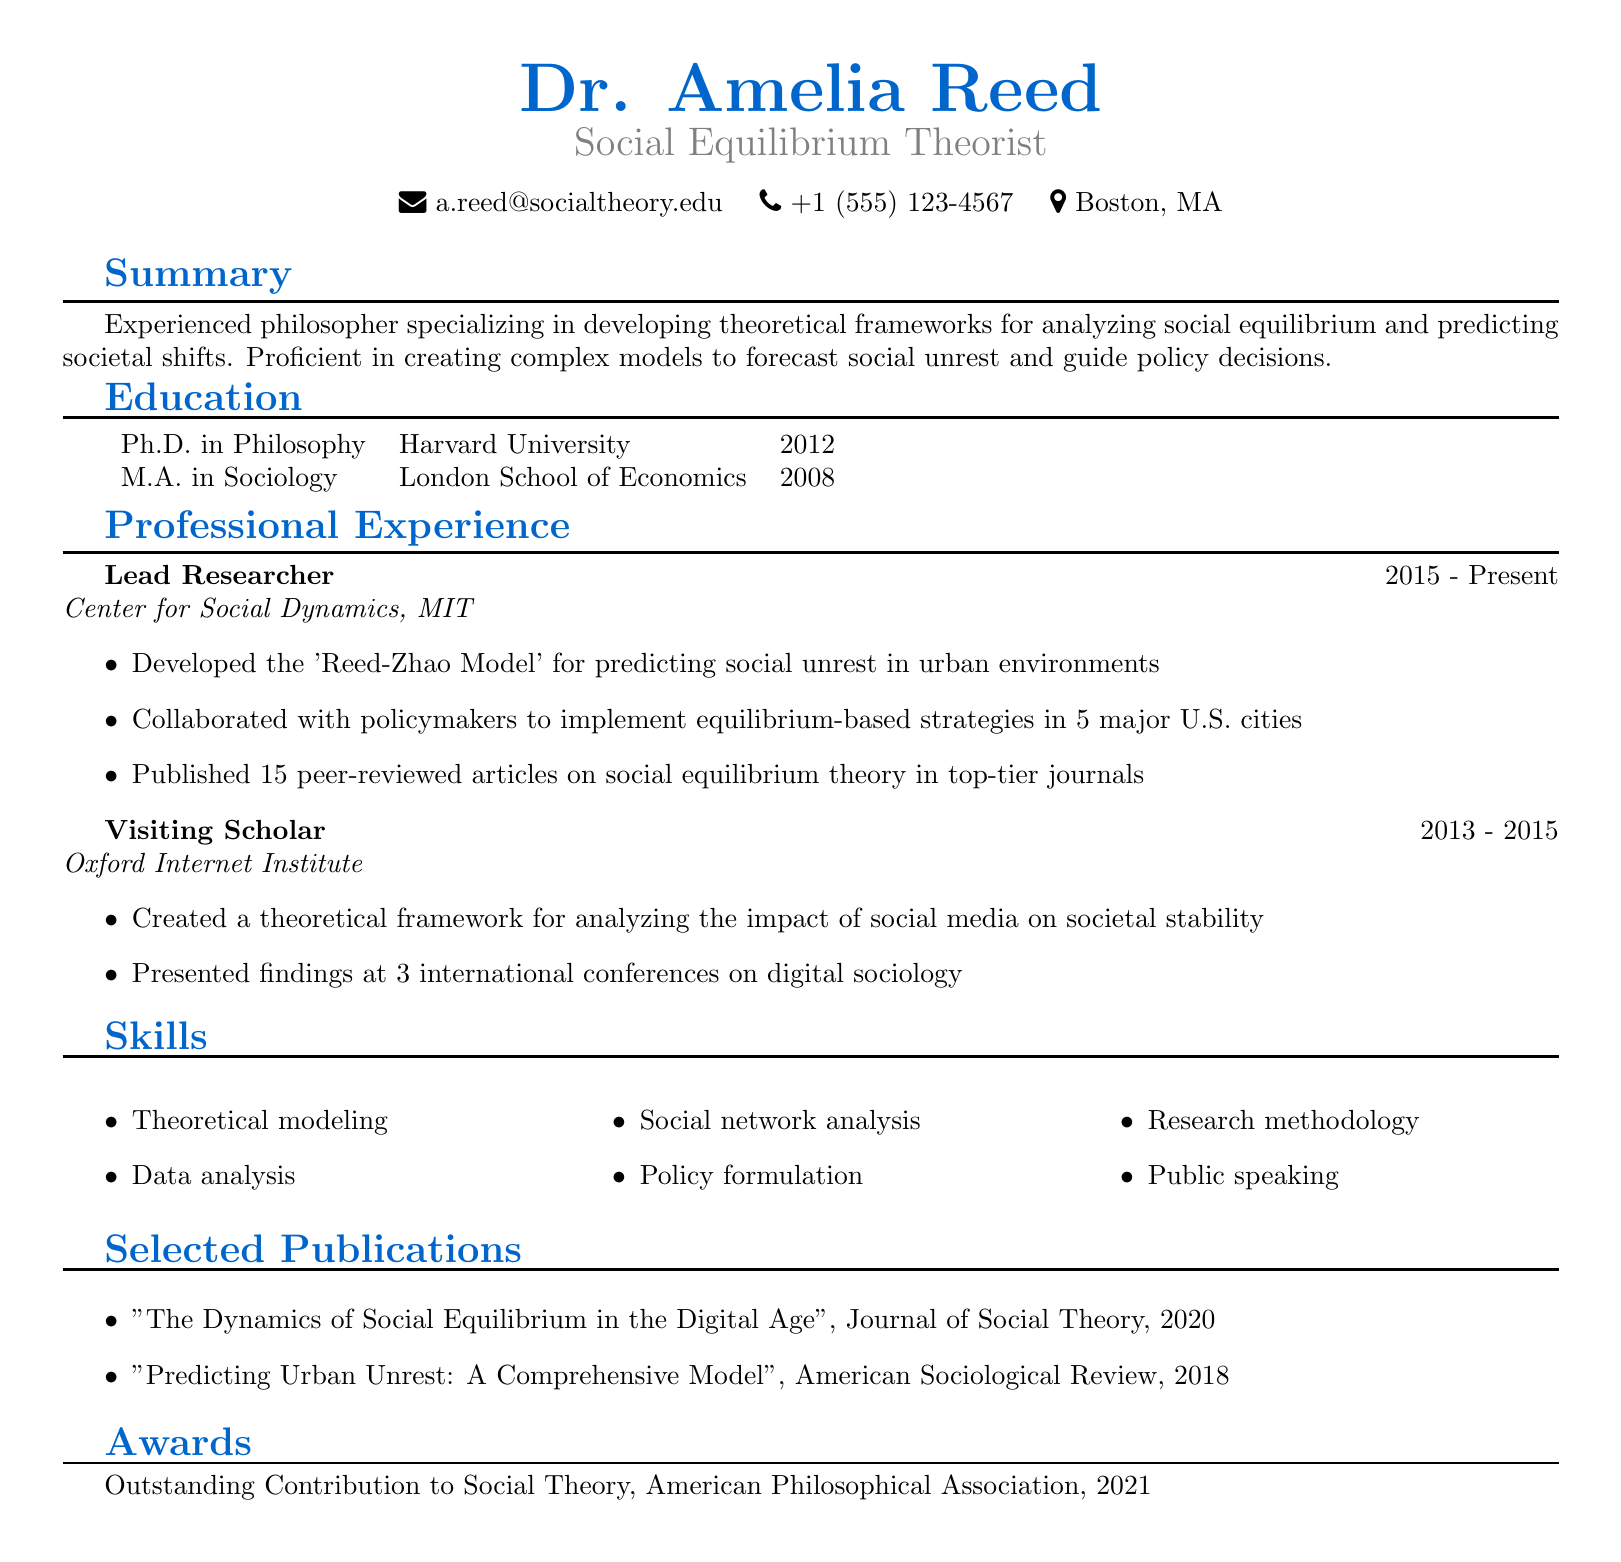what is the name of the lead researcher? The document lists the lead researcher as Dr. Amelia Reed.
Answer: Dr. Amelia Reed which institution awarded the Outstanding Contribution to Social Theory? The award is given by the American Philosophical Association.
Answer: American Philosophical Association in what year did Dr. Amelia Reed complete her Ph.D. in Philosophy? The year of completion for the Ph.D. in Philosophy is mentioned as 2012.
Answer: 2012 how many peer-reviewed articles has Dr. Amelia Reed published? The document states that Dr. Amelia Reed has published 15 peer-reviewed articles.
Answer: 15 what theoretical model did Dr. Amelia Reed develop? The document mentions the 'Reed-Zhao Model' for predicting social unrest.
Answer: Reed-Zhao Model which city has Dr. Amelia Reed implemented equilibrium-based strategies? The document states that strategies were implemented in 5 major U.S. cities.
Answer: 5 major U.S. cities what degree did Dr. Amelia Reed earn from the London School of Economics? The document lists the degree as a Master of Arts in Sociology.
Answer: M.A. in Sociology which journal published the article titled "The Dynamics of Social Equilibrium in the Digital Age"? The article was published in the Journal of Social Theory.
Answer: Journal of Social Theory what is Dr. Amelia Reed’s title? The title of Dr. Amelia Reed is Social Equilibrium Theorist.
Answer: Social Equilibrium Theorist 